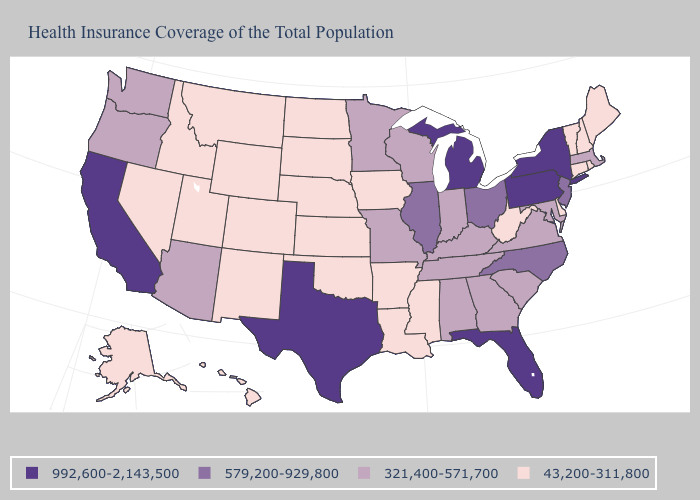What is the lowest value in the MidWest?
Answer briefly. 43,200-311,800. Does California have the highest value in the West?
Concise answer only. Yes. What is the value of Oregon?
Write a very short answer. 321,400-571,700. Name the states that have a value in the range 579,200-929,800?
Keep it brief. Illinois, New Jersey, North Carolina, Ohio. Does New Hampshire have the lowest value in the USA?
Answer briefly. Yes. How many symbols are there in the legend?
Answer briefly. 4. What is the value of Wisconsin?
Write a very short answer. 321,400-571,700. What is the value of Texas?
Keep it brief. 992,600-2,143,500. Which states hav the highest value in the West?
Keep it brief. California. Which states hav the highest value in the MidWest?
Concise answer only. Michigan. What is the value of Montana?
Quick response, please. 43,200-311,800. Does the map have missing data?
Be succinct. No. What is the highest value in the USA?
Write a very short answer. 992,600-2,143,500. Does Michigan have the same value as Vermont?
Short answer required. No. 